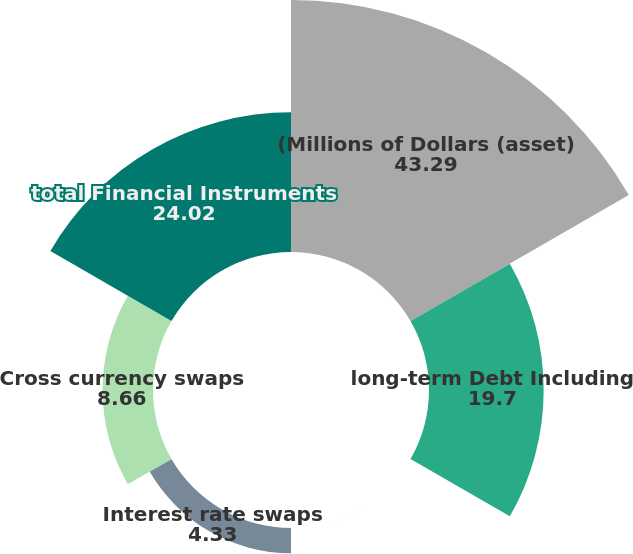Convert chart to OTSL. <chart><loc_0><loc_0><loc_500><loc_500><pie_chart><fcel>(Millions of Dollars (asset)<fcel>long-term Debt Including<fcel>Forward contracts<fcel>Interest rate swaps<fcel>Cross currency swaps<fcel>total Financial Instruments<nl><fcel>43.29%<fcel>19.7%<fcel>0.0%<fcel>4.33%<fcel>8.66%<fcel>24.02%<nl></chart> 